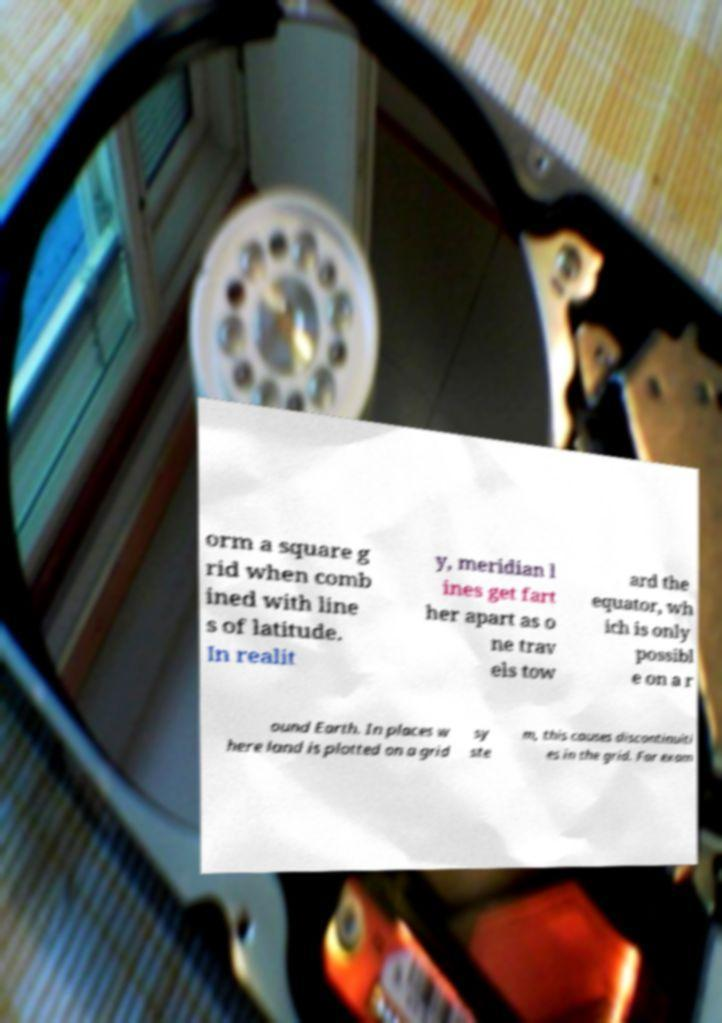Please identify and transcribe the text found in this image. orm a square g rid when comb ined with line s of latitude. In realit y, meridian l ines get fart her apart as o ne trav els tow ard the equator, wh ich is only possibl e on a r ound Earth. In places w here land is plotted on a grid sy ste m, this causes discontinuiti es in the grid. For exam 